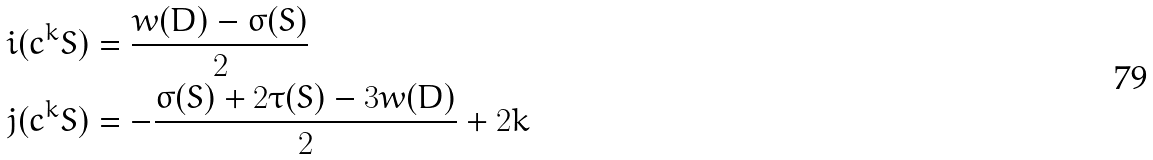<formula> <loc_0><loc_0><loc_500><loc_500>i ( c ^ { k } S ) & = \frac { w ( D ) - \sigma ( S ) } { 2 } \\ j ( c ^ { k } S ) & = - \frac { \sigma ( S ) + 2 \tau ( S ) - 3 w ( D ) } { 2 } + 2 k \\</formula> 